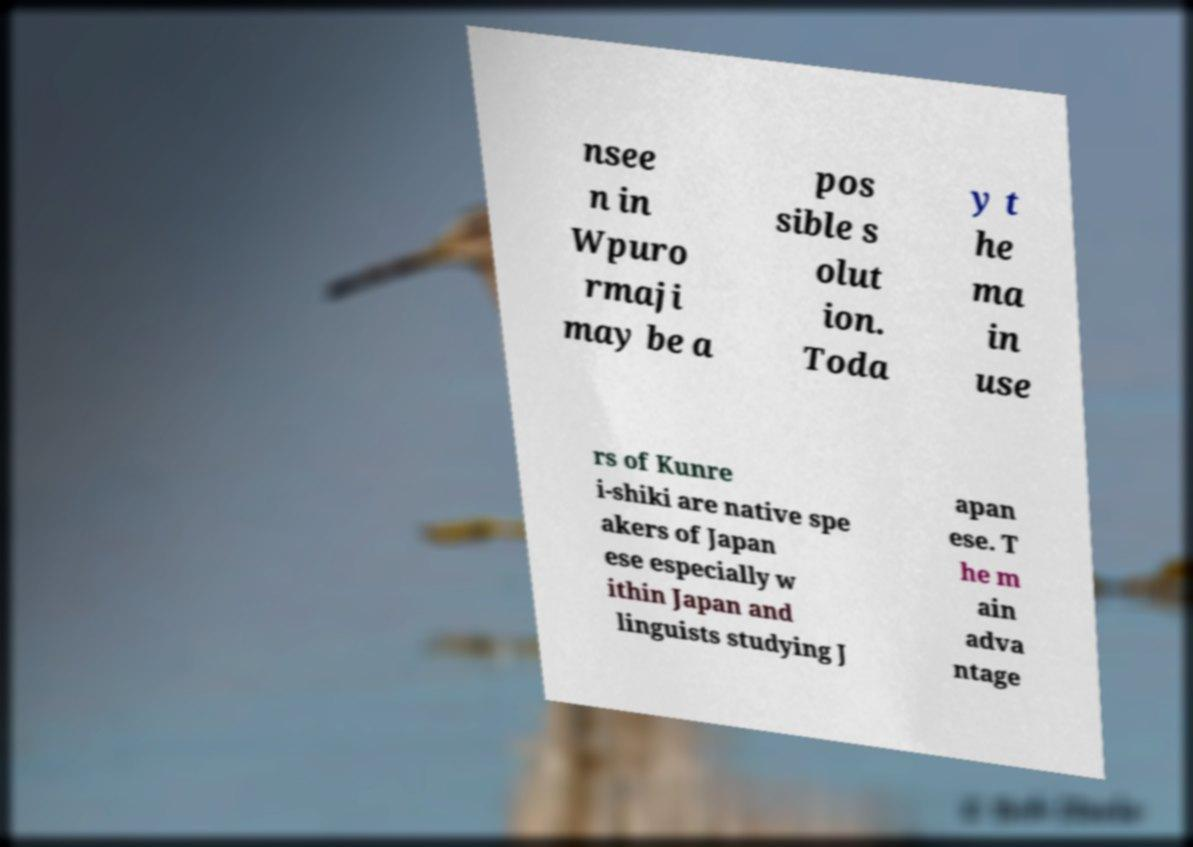I need the written content from this picture converted into text. Can you do that? nsee n in Wpuro rmaji may be a pos sible s olut ion. Toda y t he ma in use rs of Kunre i-shiki are native spe akers of Japan ese especially w ithin Japan and linguists studying J apan ese. T he m ain adva ntage 